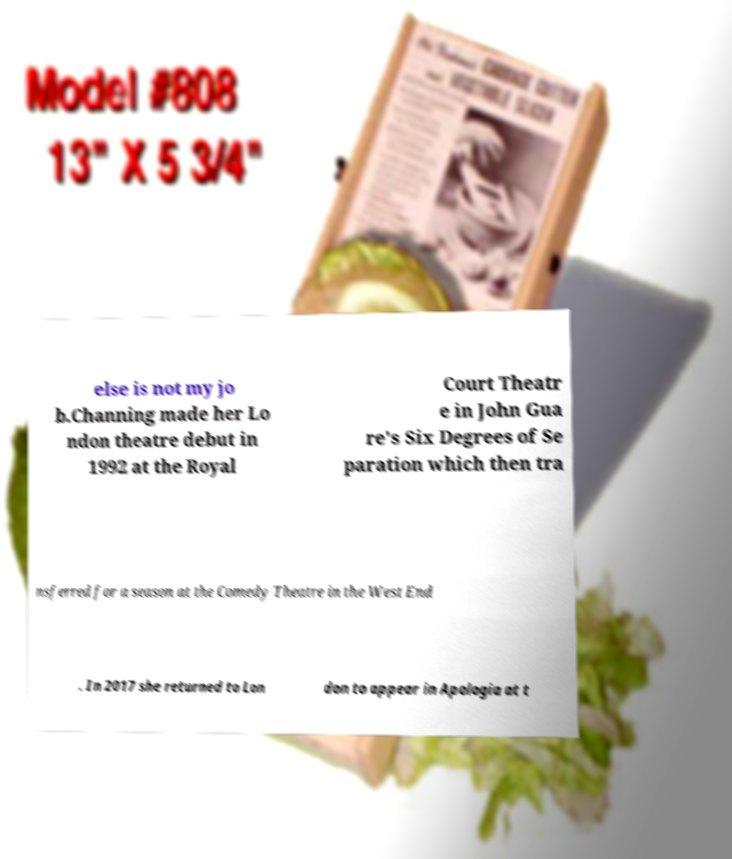Can you read and provide the text displayed in the image?This photo seems to have some interesting text. Can you extract and type it out for me? else is not my jo b.Channing made her Lo ndon theatre debut in 1992 at the Royal Court Theatr e in John Gua re's Six Degrees of Se paration which then tra nsferred for a season at the Comedy Theatre in the West End . In 2017 she returned to Lon don to appear in Apologia at t 